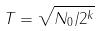Convert formula to latex. <formula><loc_0><loc_0><loc_500><loc_500>T = \sqrt { N _ { 0 } / 2 ^ { k } }</formula> 